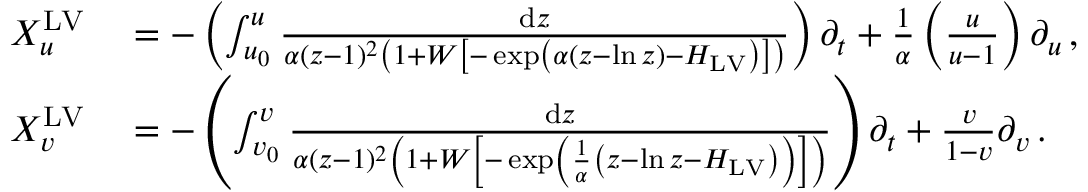<formula> <loc_0><loc_0><loc_500><loc_500>\begin{array} { r l } { X _ { u } ^ { L V } } & = - \left ( \int _ { u _ { 0 } } ^ { u } \frac { d z } { \alpha ( z - 1 ) ^ { 2 } \left ( 1 + W \left [ - \exp \left ( \alpha \left ( z - \ln z \right ) - H _ { L V } \right ) \right ] \right ) } \right ) \partial _ { t } + \frac { 1 } { \alpha } \left ( \frac { u } { u - 1 } \right ) \partial _ { u } \, , } \\ { X _ { v } ^ { L V } } & = - \left ( \int _ { v _ { 0 } } ^ { v } \frac { d z } { \alpha ( z - 1 ) ^ { 2 } \left ( 1 + W \left [ - \exp \left ( \frac { 1 } { \alpha } \left ( z - \ln z - H _ { L V } \right ) \right ) \right ] \right ) } \right ) \partial _ { t } + \frac { v } { 1 - v } \partial _ { v } \, . } \end{array}</formula> 